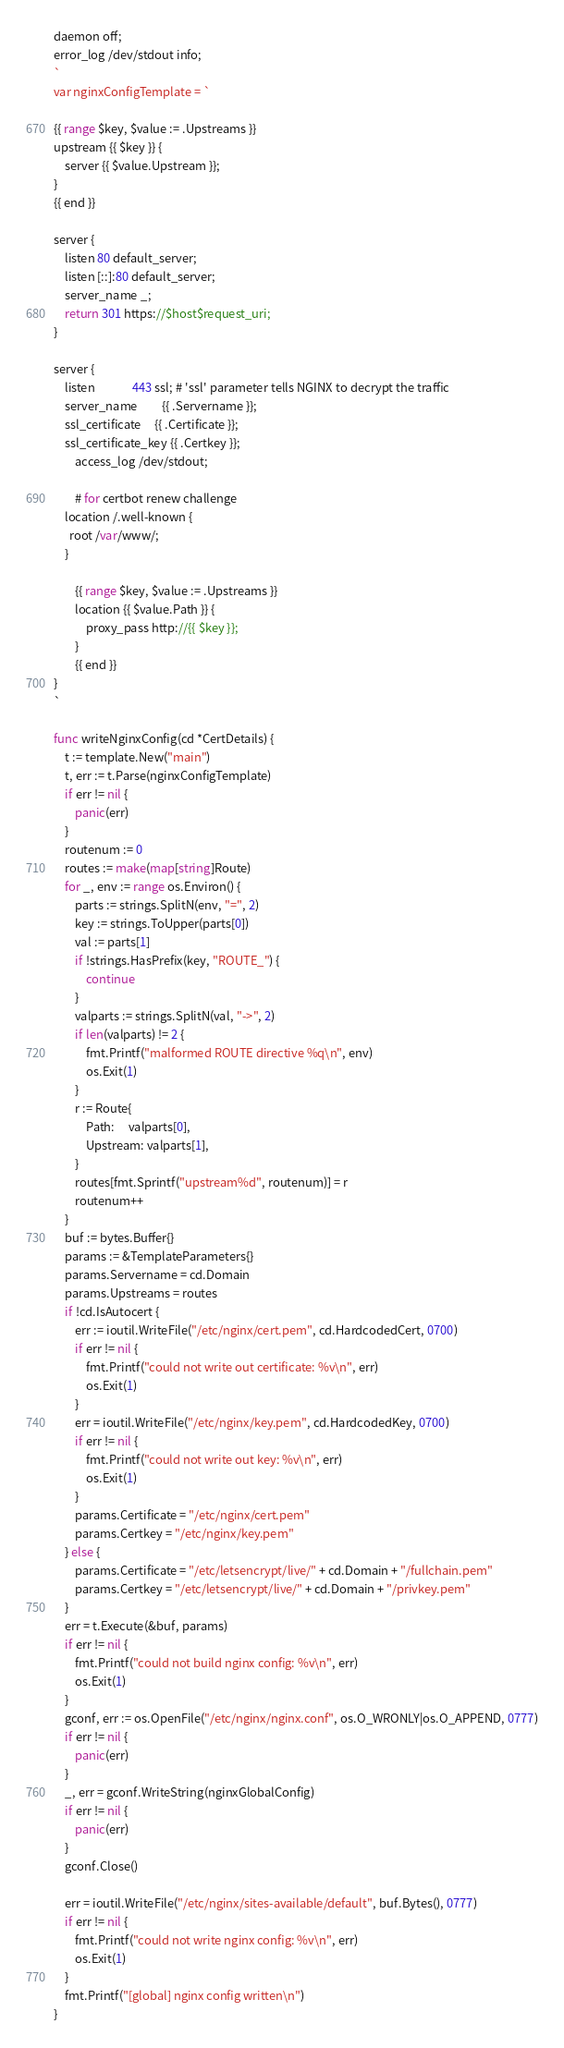<code> <loc_0><loc_0><loc_500><loc_500><_Go_>daemon off;
error_log /dev/stdout info;
`
var nginxConfigTemplate = `

{{ range $key, $value := .Upstreams }}
upstream {{ $key }} {
    server {{ $value.Upstream }};
}
{{ end }}

server {
	listen 80 default_server;
	listen [::]:80 default_server;
	server_name _;
	return 301 https://$host$request_uri;
}

server {
    listen              443 ssl; # 'ssl' parameter tells NGINX to decrypt the traffic
    server_name         {{ .Servername }};
    ssl_certificate     {{ .Certificate }};
    ssl_certificate_key {{ .Certkey }};
		access_log /dev/stdout;

		# for certbot renew challenge
    location /.well-known {
      root /var/www/;
    }

		{{ range $key, $value := .Upstreams }}
		location {{ $value.Path }} {
			proxy_pass http://{{ $key }};
		}
		{{ end }}
}
`

func writeNginxConfig(cd *CertDetails) {
	t := template.New("main")
	t, err := t.Parse(nginxConfigTemplate)
	if err != nil {
		panic(err)
	}
	routenum := 0
	routes := make(map[string]Route)
	for _, env := range os.Environ() {
		parts := strings.SplitN(env, "=", 2)
		key := strings.ToUpper(parts[0])
		val := parts[1]
		if !strings.HasPrefix(key, "ROUTE_") {
			continue
		}
		valparts := strings.SplitN(val, "->", 2)
		if len(valparts) != 2 {
			fmt.Printf("malformed ROUTE directive %q\n", env)
			os.Exit(1)
		}
		r := Route{
			Path:     valparts[0],
			Upstream: valparts[1],
		}
		routes[fmt.Sprintf("upstream%d", routenum)] = r
		routenum++
	}
	buf := bytes.Buffer{}
	params := &TemplateParameters{}
	params.Servername = cd.Domain
	params.Upstreams = routes
	if !cd.IsAutocert {
		err := ioutil.WriteFile("/etc/nginx/cert.pem", cd.HardcodedCert, 0700)
		if err != nil {
			fmt.Printf("could not write out certificate: %v\n", err)
			os.Exit(1)
		}
		err = ioutil.WriteFile("/etc/nginx/key.pem", cd.HardcodedKey, 0700)
		if err != nil {
			fmt.Printf("could not write out key: %v\n", err)
			os.Exit(1)
		}
		params.Certificate = "/etc/nginx/cert.pem"
		params.Certkey = "/etc/nginx/key.pem"
	} else {
		params.Certificate = "/etc/letsencrypt/live/" + cd.Domain + "/fullchain.pem"
		params.Certkey = "/etc/letsencrypt/live/" + cd.Domain + "/privkey.pem"
	}
	err = t.Execute(&buf, params)
	if err != nil {
		fmt.Printf("could not build nginx config: %v\n", err)
		os.Exit(1)
	}
	gconf, err := os.OpenFile("/etc/nginx/nginx.conf", os.O_WRONLY|os.O_APPEND, 0777)
	if err != nil {
		panic(err)
	}
	_, err = gconf.WriteString(nginxGlobalConfig)
	if err != nil {
		panic(err)
	}
	gconf.Close()

	err = ioutil.WriteFile("/etc/nginx/sites-available/default", buf.Bytes(), 0777)
	if err != nil {
		fmt.Printf("could not write nginx config: %v\n", err)
		os.Exit(1)
	}
	fmt.Printf("[global] nginx config written\n")
}
</code> 